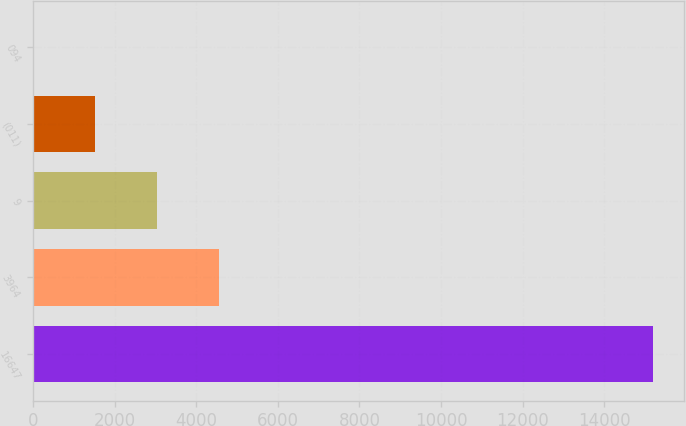<chart> <loc_0><loc_0><loc_500><loc_500><bar_chart><fcel>16647<fcel>3964<fcel>9<fcel>(011)<fcel>094<nl><fcel>15197<fcel>4559.83<fcel>3040.24<fcel>1520.65<fcel>1.06<nl></chart> 